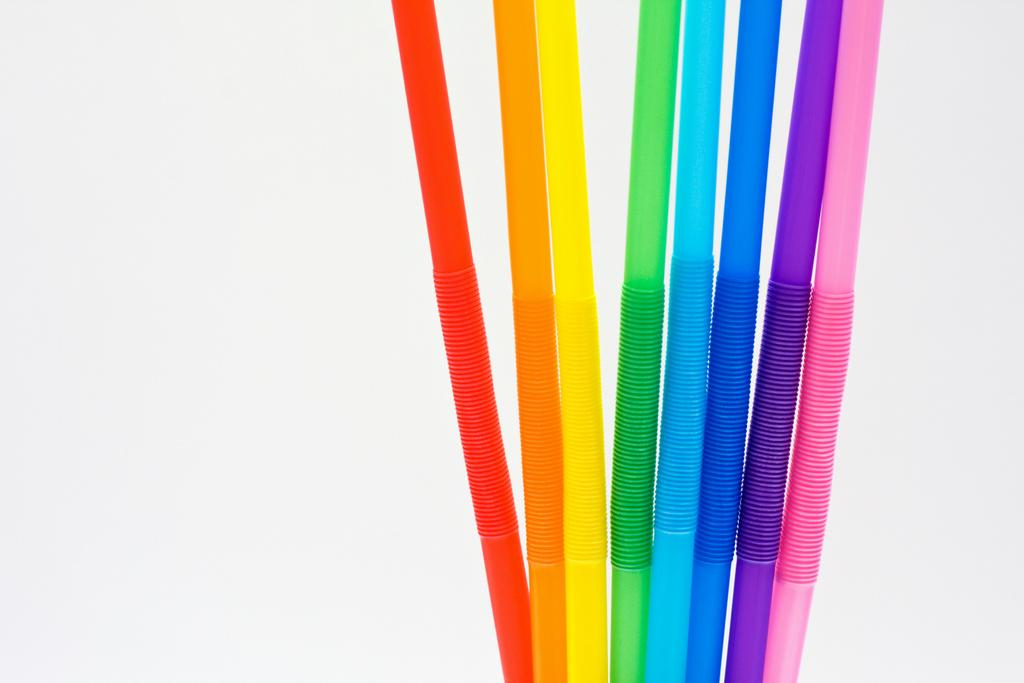What type of objects can be seen in the image? There are many different color straws in the image. Can you describe the appearance of the straws? The straws come in various colors. What is the plot of the story unfolding in the image? There is no story or plot present in the image, as it only features straws of different colors. What type of food can be smelled in the image? There is no food present in the image, and therefore no smell can be associated with it. 